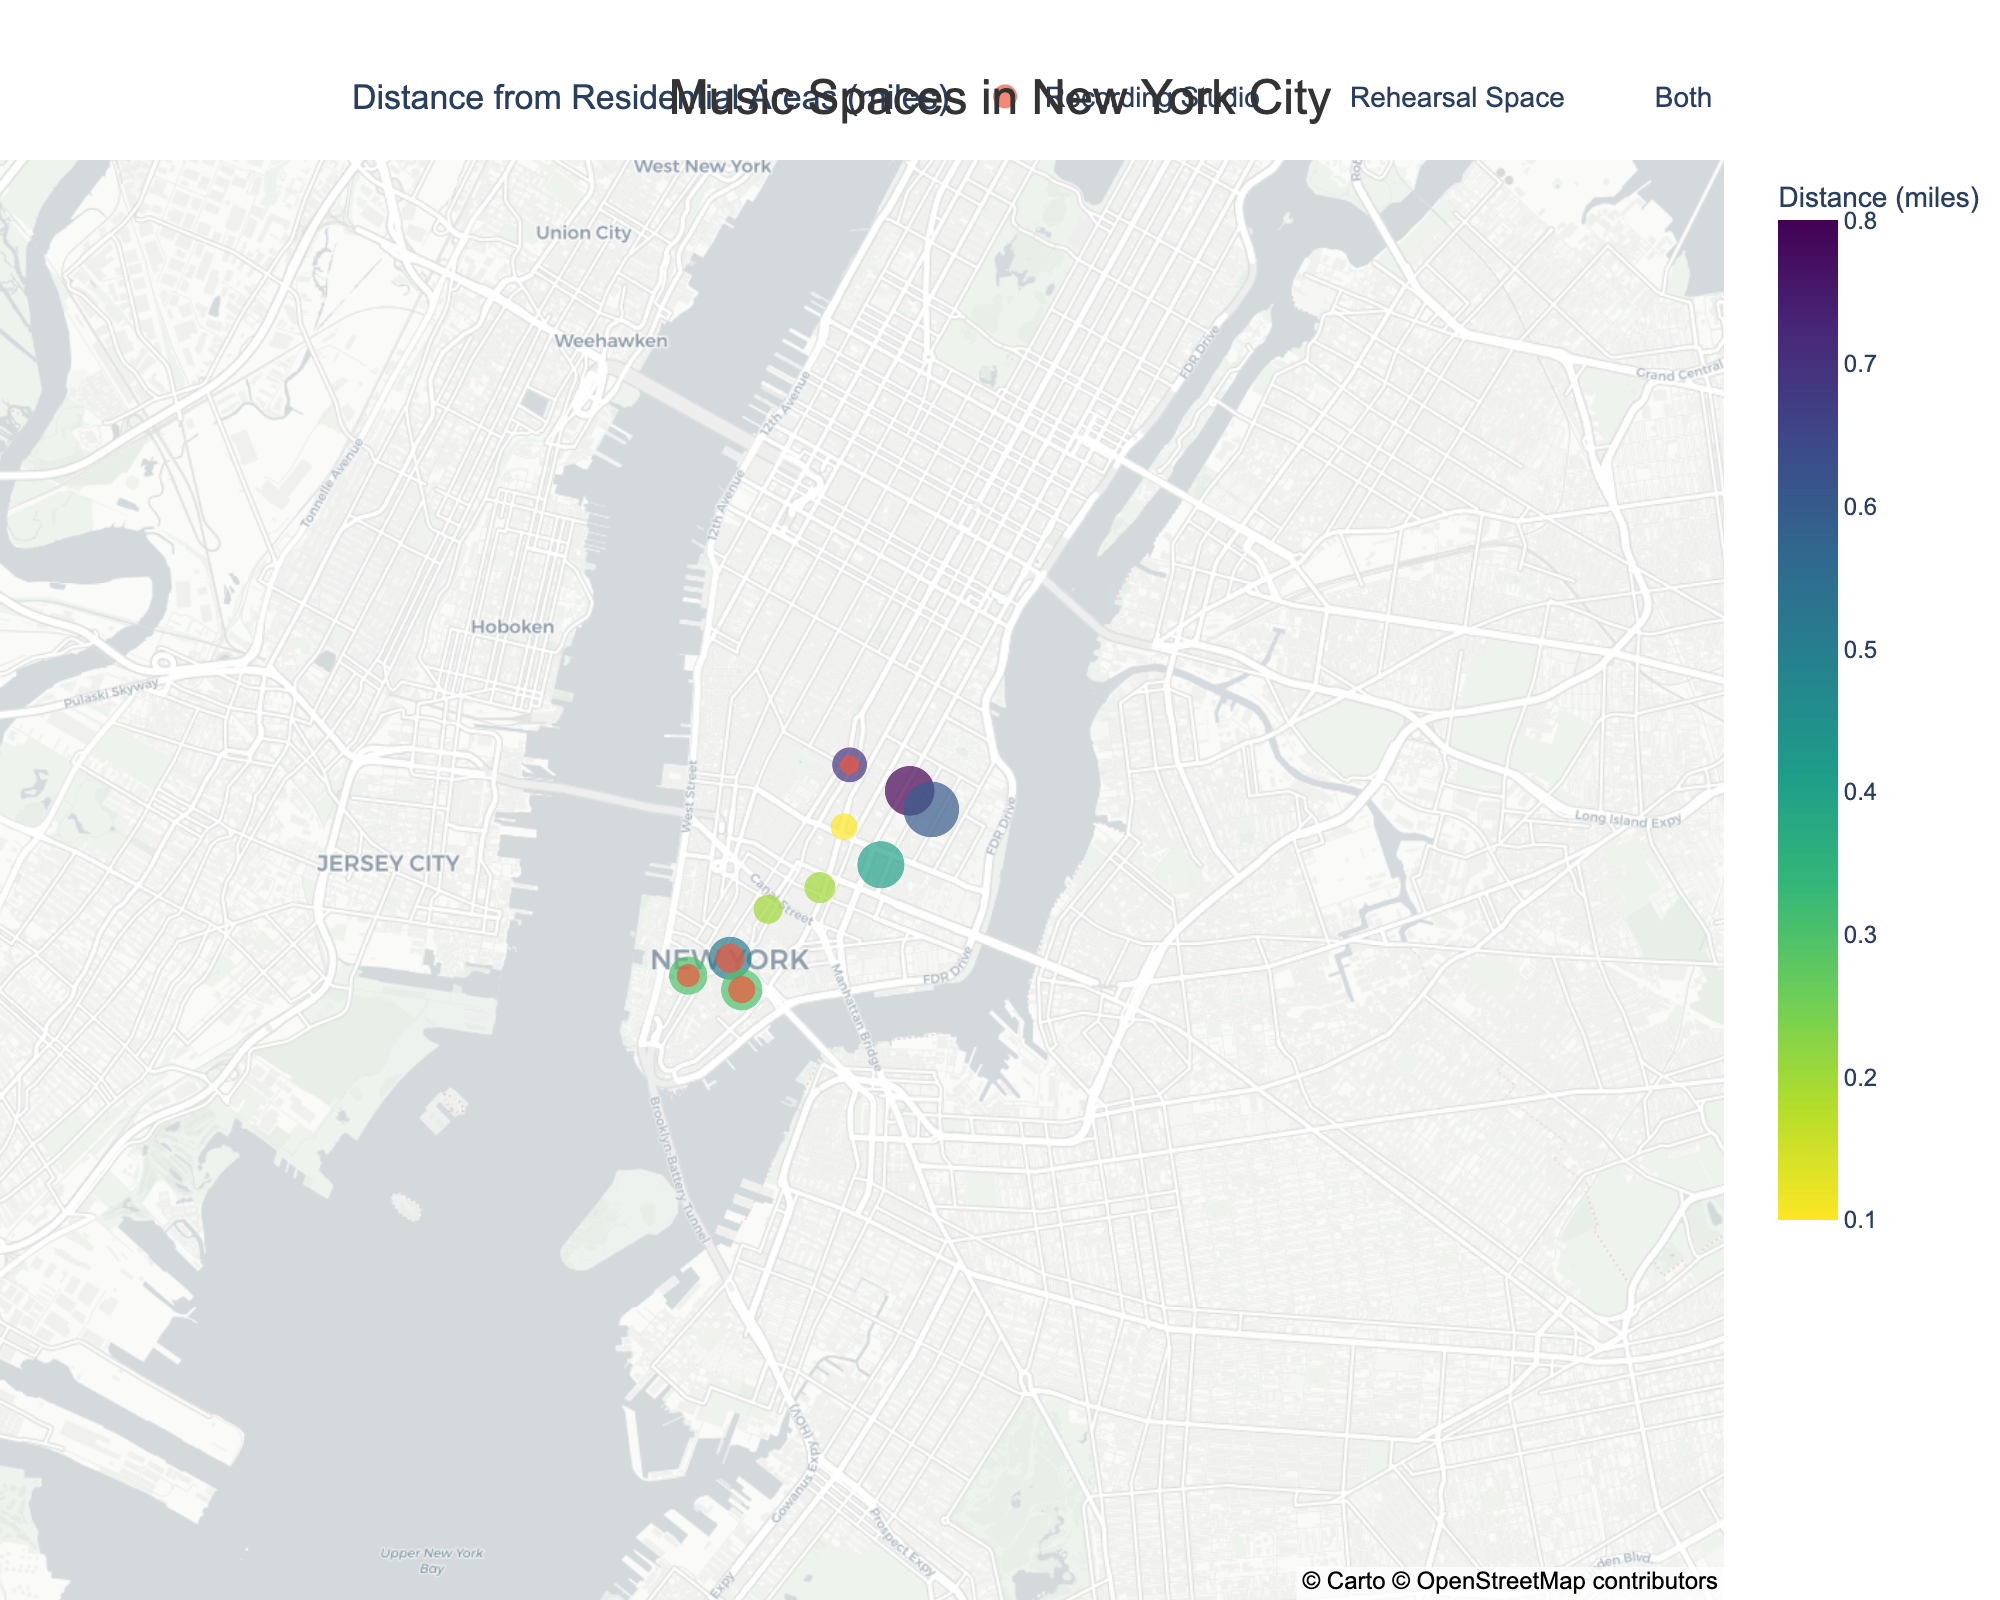How many music spaces are plotted in the figure? Count the number of markers representing both rehearsal spaces and recording studios on the plot. There are 10 data points: SoHo Sound Studio, East Village Rehearsal Space, Williamsburg Music Hub, TriBeCa Tunes, Lower East Side Jam Room, Alphabet City Audio, Greenpoint Grooves, West Village Music Loft, Brooklyn Beat Factory, and Downtown Sound Lab.
Answer: 10 Which music space is located closest to a residential area? By identifying the marker with the smallest "Distance from Residential" value, we see that Lower East Side Jam Room is closest to a residential area with a distance of 0.1 miles.
Answer: Lower East Side Jam Room What is the average capacity of all the music spaces combined? To find the average capacity, sum all the capacities and divide by the number of music spaces. The total capacity is 15 + 8 + 20 + 12 + 6 + 18 + 10 + 7 + 25 + 14 = 135. There are 10 music spaces. So, the average capacity is 135 ÷ 10 = 13.5.
Answer: 13.5 Which type of music space is more prevalent within 0.3 miles of residential areas? Count the markers within 0.3 miles from residential areas and categorize them by type. The spaces within 0.3 miles are: East Village Rehearsal Space (Rehearsal Space), TriBeCa Tunes (Recording Studio), Lower East Side Jam Room (Rehearsal Space), Downtown Sound Lab (Recording Studio). Rehearsal and Recording spaces are equal with a count of 2 each.
Answer: Equal (2 each) Which music space has the largest capacity and how far is it from the nearest residential area? By observing the size of markers (capacity) on the plot, Brooklyn Beat Factory has the largest capacity of 25. The distance from the nearest residential area for Brooklyn Beat Factory is 0.6 miles.
Answer: Brooklyn Beat Factory, 0.6 miles Do recording studios or rehearsal spaces tend to be closer to residential areas on average? First, identify distances for each type. Recording Studio distances: 0.5, 0.3, 0.3, 0.7. Rehearsal Space distances: 0.2, 0.1, 0.2. Average for Recording Studio: (0.5 + 0.3 + 0.3 + 0.7) / 4 = 0.45. Average for Rehearsal Space: (0.2 + 0.1 + 0.2) / 3 = 0.167. Rehearsal Spaces tend to be closer to residential areas.
Answer: Rehearsal Spaces 